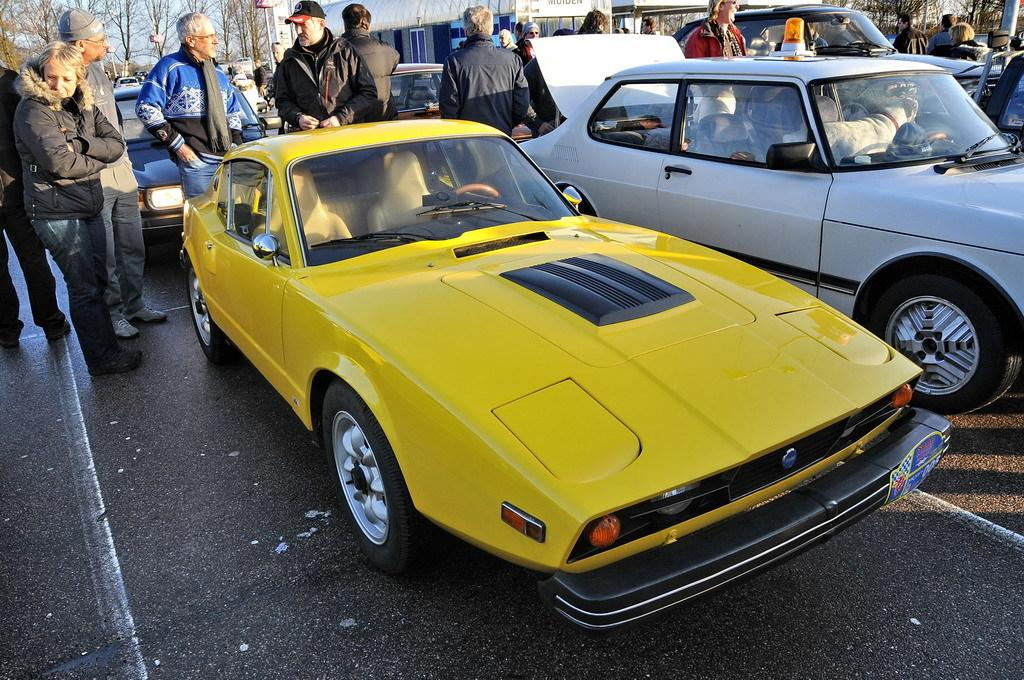What can be seen in the foreground of the image? There are vehicles on the road and persons standing around the vehicles in the foreground of the image. What is visible in the background of the image? Poles, a room, trees, and the sky are visible in the background of the image. How many cats can be seen playing with the pollution in the image? There are no cats or pollution present in the image. What type of weather can be observed in the image? The provided facts do not mention any weather conditions, so it cannot be determined from the image. 